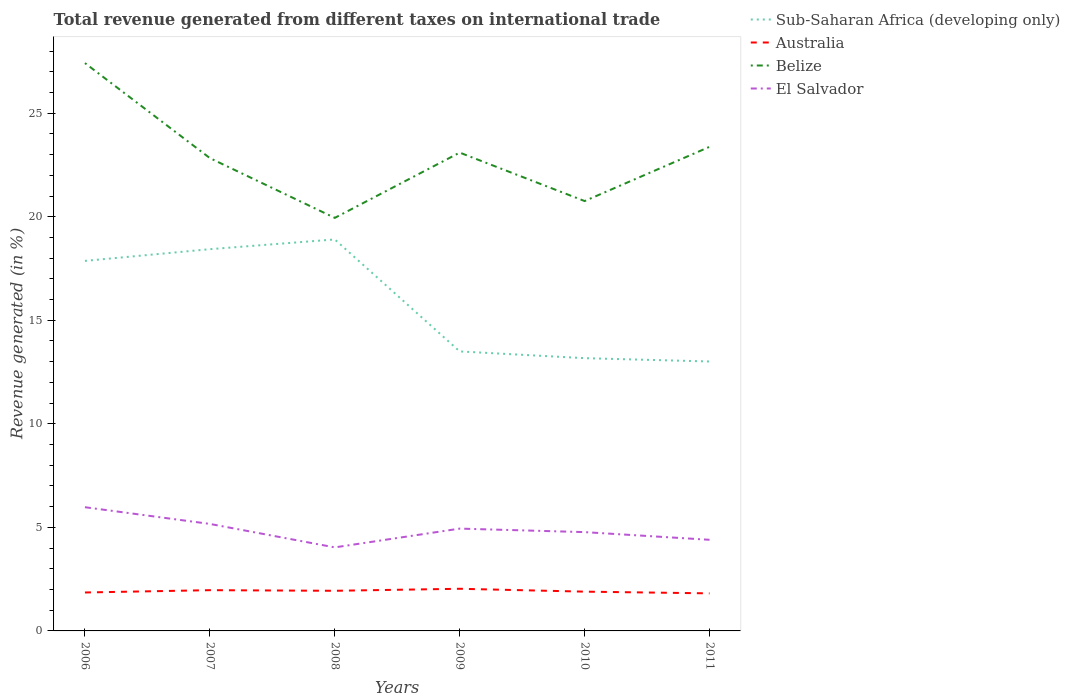How many different coloured lines are there?
Provide a short and direct response. 4. Does the line corresponding to Australia intersect with the line corresponding to Belize?
Your answer should be very brief. No. Across all years, what is the maximum total revenue generated in Sub-Saharan Africa (developing only)?
Offer a terse response. 13.01. In which year was the total revenue generated in Sub-Saharan Africa (developing only) maximum?
Offer a terse response. 2011. What is the total total revenue generated in Australia in the graph?
Give a very brief answer. 0.08. What is the difference between the highest and the second highest total revenue generated in Belize?
Your answer should be very brief. 7.47. Is the total revenue generated in El Salvador strictly greater than the total revenue generated in Belize over the years?
Keep it short and to the point. Yes. What is the difference between two consecutive major ticks on the Y-axis?
Ensure brevity in your answer.  5. Does the graph contain any zero values?
Provide a succinct answer. No. Where does the legend appear in the graph?
Your answer should be compact. Top right. What is the title of the graph?
Provide a short and direct response. Total revenue generated from different taxes on international trade. Does "Korea (Democratic)" appear as one of the legend labels in the graph?
Your answer should be very brief. No. What is the label or title of the Y-axis?
Offer a very short reply. Revenue generated (in %). What is the Revenue generated (in %) in Sub-Saharan Africa (developing only) in 2006?
Your answer should be compact. 17.87. What is the Revenue generated (in %) in Australia in 2006?
Your answer should be very brief. 1.86. What is the Revenue generated (in %) of Belize in 2006?
Offer a very short reply. 27.42. What is the Revenue generated (in %) of El Salvador in 2006?
Your answer should be compact. 5.97. What is the Revenue generated (in %) of Sub-Saharan Africa (developing only) in 2007?
Your response must be concise. 18.43. What is the Revenue generated (in %) of Australia in 2007?
Offer a terse response. 1.97. What is the Revenue generated (in %) in Belize in 2007?
Keep it short and to the point. 22.83. What is the Revenue generated (in %) of El Salvador in 2007?
Provide a succinct answer. 5.17. What is the Revenue generated (in %) of Sub-Saharan Africa (developing only) in 2008?
Provide a short and direct response. 18.9. What is the Revenue generated (in %) in Australia in 2008?
Provide a succinct answer. 1.94. What is the Revenue generated (in %) of Belize in 2008?
Keep it short and to the point. 19.94. What is the Revenue generated (in %) of El Salvador in 2008?
Provide a short and direct response. 4.03. What is the Revenue generated (in %) of Sub-Saharan Africa (developing only) in 2009?
Ensure brevity in your answer.  13.5. What is the Revenue generated (in %) in Australia in 2009?
Give a very brief answer. 2.04. What is the Revenue generated (in %) of Belize in 2009?
Keep it short and to the point. 23.1. What is the Revenue generated (in %) in El Salvador in 2009?
Ensure brevity in your answer.  4.94. What is the Revenue generated (in %) in Sub-Saharan Africa (developing only) in 2010?
Your answer should be very brief. 13.17. What is the Revenue generated (in %) of Australia in 2010?
Your answer should be very brief. 1.9. What is the Revenue generated (in %) of Belize in 2010?
Your answer should be very brief. 20.76. What is the Revenue generated (in %) in El Salvador in 2010?
Your response must be concise. 4.77. What is the Revenue generated (in %) of Sub-Saharan Africa (developing only) in 2011?
Provide a short and direct response. 13.01. What is the Revenue generated (in %) of Australia in 2011?
Your answer should be compact. 1.81. What is the Revenue generated (in %) of Belize in 2011?
Offer a very short reply. 23.37. What is the Revenue generated (in %) of El Salvador in 2011?
Your answer should be very brief. 4.4. Across all years, what is the maximum Revenue generated (in %) in Sub-Saharan Africa (developing only)?
Provide a succinct answer. 18.9. Across all years, what is the maximum Revenue generated (in %) in Australia?
Offer a terse response. 2.04. Across all years, what is the maximum Revenue generated (in %) of Belize?
Your answer should be compact. 27.42. Across all years, what is the maximum Revenue generated (in %) in El Salvador?
Offer a terse response. 5.97. Across all years, what is the minimum Revenue generated (in %) in Sub-Saharan Africa (developing only)?
Provide a short and direct response. 13.01. Across all years, what is the minimum Revenue generated (in %) of Australia?
Keep it short and to the point. 1.81. Across all years, what is the minimum Revenue generated (in %) in Belize?
Your response must be concise. 19.94. Across all years, what is the minimum Revenue generated (in %) in El Salvador?
Your answer should be compact. 4.03. What is the total Revenue generated (in %) of Sub-Saharan Africa (developing only) in the graph?
Provide a succinct answer. 94.88. What is the total Revenue generated (in %) in Australia in the graph?
Your answer should be very brief. 11.51. What is the total Revenue generated (in %) in Belize in the graph?
Keep it short and to the point. 137.42. What is the total Revenue generated (in %) in El Salvador in the graph?
Your answer should be compact. 29.28. What is the difference between the Revenue generated (in %) in Sub-Saharan Africa (developing only) in 2006 and that in 2007?
Your answer should be very brief. -0.57. What is the difference between the Revenue generated (in %) of Australia in 2006 and that in 2007?
Offer a terse response. -0.11. What is the difference between the Revenue generated (in %) in Belize in 2006 and that in 2007?
Your answer should be compact. 4.59. What is the difference between the Revenue generated (in %) in El Salvador in 2006 and that in 2007?
Make the answer very short. 0.81. What is the difference between the Revenue generated (in %) in Sub-Saharan Africa (developing only) in 2006 and that in 2008?
Provide a succinct answer. -1.04. What is the difference between the Revenue generated (in %) in Australia in 2006 and that in 2008?
Your answer should be compact. -0.08. What is the difference between the Revenue generated (in %) in Belize in 2006 and that in 2008?
Make the answer very short. 7.47. What is the difference between the Revenue generated (in %) of El Salvador in 2006 and that in 2008?
Your answer should be very brief. 1.94. What is the difference between the Revenue generated (in %) in Sub-Saharan Africa (developing only) in 2006 and that in 2009?
Make the answer very short. 4.37. What is the difference between the Revenue generated (in %) of Australia in 2006 and that in 2009?
Offer a very short reply. -0.18. What is the difference between the Revenue generated (in %) of Belize in 2006 and that in 2009?
Your answer should be compact. 4.32. What is the difference between the Revenue generated (in %) of El Salvador in 2006 and that in 2009?
Your answer should be very brief. 1.03. What is the difference between the Revenue generated (in %) of Sub-Saharan Africa (developing only) in 2006 and that in 2010?
Ensure brevity in your answer.  4.7. What is the difference between the Revenue generated (in %) in Australia in 2006 and that in 2010?
Your answer should be very brief. -0.04. What is the difference between the Revenue generated (in %) in Belize in 2006 and that in 2010?
Your answer should be compact. 6.66. What is the difference between the Revenue generated (in %) of El Salvador in 2006 and that in 2010?
Make the answer very short. 1.2. What is the difference between the Revenue generated (in %) of Sub-Saharan Africa (developing only) in 2006 and that in 2011?
Your response must be concise. 4.86. What is the difference between the Revenue generated (in %) in Australia in 2006 and that in 2011?
Keep it short and to the point. 0.04. What is the difference between the Revenue generated (in %) in Belize in 2006 and that in 2011?
Your answer should be very brief. 4.04. What is the difference between the Revenue generated (in %) in El Salvador in 2006 and that in 2011?
Provide a short and direct response. 1.57. What is the difference between the Revenue generated (in %) in Sub-Saharan Africa (developing only) in 2007 and that in 2008?
Keep it short and to the point. -0.47. What is the difference between the Revenue generated (in %) in Australia in 2007 and that in 2008?
Give a very brief answer. 0.03. What is the difference between the Revenue generated (in %) in Belize in 2007 and that in 2008?
Give a very brief answer. 2.89. What is the difference between the Revenue generated (in %) in El Salvador in 2007 and that in 2008?
Offer a terse response. 1.13. What is the difference between the Revenue generated (in %) of Sub-Saharan Africa (developing only) in 2007 and that in 2009?
Offer a terse response. 4.94. What is the difference between the Revenue generated (in %) in Australia in 2007 and that in 2009?
Your answer should be compact. -0.07. What is the difference between the Revenue generated (in %) in Belize in 2007 and that in 2009?
Offer a very short reply. -0.27. What is the difference between the Revenue generated (in %) of El Salvador in 2007 and that in 2009?
Provide a short and direct response. 0.23. What is the difference between the Revenue generated (in %) in Sub-Saharan Africa (developing only) in 2007 and that in 2010?
Keep it short and to the point. 5.26. What is the difference between the Revenue generated (in %) in Australia in 2007 and that in 2010?
Ensure brevity in your answer.  0.07. What is the difference between the Revenue generated (in %) of Belize in 2007 and that in 2010?
Your answer should be very brief. 2.07. What is the difference between the Revenue generated (in %) in El Salvador in 2007 and that in 2010?
Make the answer very short. 0.4. What is the difference between the Revenue generated (in %) in Sub-Saharan Africa (developing only) in 2007 and that in 2011?
Ensure brevity in your answer.  5.42. What is the difference between the Revenue generated (in %) in Australia in 2007 and that in 2011?
Keep it short and to the point. 0.15. What is the difference between the Revenue generated (in %) of Belize in 2007 and that in 2011?
Offer a terse response. -0.54. What is the difference between the Revenue generated (in %) in El Salvador in 2007 and that in 2011?
Your answer should be very brief. 0.77. What is the difference between the Revenue generated (in %) in Sub-Saharan Africa (developing only) in 2008 and that in 2009?
Give a very brief answer. 5.41. What is the difference between the Revenue generated (in %) in Australia in 2008 and that in 2009?
Your answer should be compact. -0.1. What is the difference between the Revenue generated (in %) of Belize in 2008 and that in 2009?
Your answer should be compact. -3.15. What is the difference between the Revenue generated (in %) of El Salvador in 2008 and that in 2009?
Ensure brevity in your answer.  -0.91. What is the difference between the Revenue generated (in %) in Sub-Saharan Africa (developing only) in 2008 and that in 2010?
Provide a succinct answer. 5.73. What is the difference between the Revenue generated (in %) of Australia in 2008 and that in 2010?
Give a very brief answer. 0.04. What is the difference between the Revenue generated (in %) in Belize in 2008 and that in 2010?
Give a very brief answer. -0.81. What is the difference between the Revenue generated (in %) of El Salvador in 2008 and that in 2010?
Provide a short and direct response. -0.74. What is the difference between the Revenue generated (in %) in Sub-Saharan Africa (developing only) in 2008 and that in 2011?
Provide a short and direct response. 5.89. What is the difference between the Revenue generated (in %) in Australia in 2008 and that in 2011?
Your response must be concise. 0.12. What is the difference between the Revenue generated (in %) in Belize in 2008 and that in 2011?
Ensure brevity in your answer.  -3.43. What is the difference between the Revenue generated (in %) of El Salvador in 2008 and that in 2011?
Provide a succinct answer. -0.37. What is the difference between the Revenue generated (in %) of Sub-Saharan Africa (developing only) in 2009 and that in 2010?
Your answer should be compact. 0.33. What is the difference between the Revenue generated (in %) in Australia in 2009 and that in 2010?
Provide a succinct answer. 0.14. What is the difference between the Revenue generated (in %) of Belize in 2009 and that in 2010?
Provide a short and direct response. 2.34. What is the difference between the Revenue generated (in %) in El Salvador in 2009 and that in 2010?
Give a very brief answer. 0.17. What is the difference between the Revenue generated (in %) in Sub-Saharan Africa (developing only) in 2009 and that in 2011?
Your answer should be compact. 0.49. What is the difference between the Revenue generated (in %) in Australia in 2009 and that in 2011?
Offer a terse response. 0.22. What is the difference between the Revenue generated (in %) in Belize in 2009 and that in 2011?
Provide a short and direct response. -0.28. What is the difference between the Revenue generated (in %) in El Salvador in 2009 and that in 2011?
Provide a succinct answer. 0.54. What is the difference between the Revenue generated (in %) of Sub-Saharan Africa (developing only) in 2010 and that in 2011?
Your answer should be compact. 0.16. What is the difference between the Revenue generated (in %) in Australia in 2010 and that in 2011?
Provide a succinct answer. 0.08. What is the difference between the Revenue generated (in %) in Belize in 2010 and that in 2011?
Ensure brevity in your answer.  -2.62. What is the difference between the Revenue generated (in %) in El Salvador in 2010 and that in 2011?
Your answer should be compact. 0.37. What is the difference between the Revenue generated (in %) of Sub-Saharan Africa (developing only) in 2006 and the Revenue generated (in %) of Australia in 2007?
Provide a succinct answer. 15.9. What is the difference between the Revenue generated (in %) in Sub-Saharan Africa (developing only) in 2006 and the Revenue generated (in %) in Belize in 2007?
Your response must be concise. -4.96. What is the difference between the Revenue generated (in %) of Sub-Saharan Africa (developing only) in 2006 and the Revenue generated (in %) of El Salvador in 2007?
Make the answer very short. 12.7. What is the difference between the Revenue generated (in %) in Australia in 2006 and the Revenue generated (in %) in Belize in 2007?
Ensure brevity in your answer.  -20.97. What is the difference between the Revenue generated (in %) in Australia in 2006 and the Revenue generated (in %) in El Salvador in 2007?
Provide a short and direct response. -3.31. What is the difference between the Revenue generated (in %) in Belize in 2006 and the Revenue generated (in %) in El Salvador in 2007?
Ensure brevity in your answer.  22.25. What is the difference between the Revenue generated (in %) of Sub-Saharan Africa (developing only) in 2006 and the Revenue generated (in %) of Australia in 2008?
Provide a short and direct response. 15.93. What is the difference between the Revenue generated (in %) in Sub-Saharan Africa (developing only) in 2006 and the Revenue generated (in %) in Belize in 2008?
Offer a terse response. -2.08. What is the difference between the Revenue generated (in %) of Sub-Saharan Africa (developing only) in 2006 and the Revenue generated (in %) of El Salvador in 2008?
Offer a very short reply. 13.83. What is the difference between the Revenue generated (in %) of Australia in 2006 and the Revenue generated (in %) of Belize in 2008?
Your response must be concise. -18.09. What is the difference between the Revenue generated (in %) of Australia in 2006 and the Revenue generated (in %) of El Salvador in 2008?
Ensure brevity in your answer.  -2.18. What is the difference between the Revenue generated (in %) in Belize in 2006 and the Revenue generated (in %) in El Salvador in 2008?
Provide a short and direct response. 23.38. What is the difference between the Revenue generated (in %) in Sub-Saharan Africa (developing only) in 2006 and the Revenue generated (in %) in Australia in 2009?
Your response must be concise. 15.83. What is the difference between the Revenue generated (in %) in Sub-Saharan Africa (developing only) in 2006 and the Revenue generated (in %) in Belize in 2009?
Provide a succinct answer. -5.23. What is the difference between the Revenue generated (in %) in Sub-Saharan Africa (developing only) in 2006 and the Revenue generated (in %) in El Salvador in 2009?
Your answer should be compact. 12.93. What is the difference between the Revenue generated (in %) of Australia in 2006 and the Revenue generated (in %) of Belize in 2009?
Keep it short and to the point. -21.24. What is the difference between the Revenue generated (in %) of Australia in 2006 and the Revenue generated (in %) of El Salvador in 2009?
Your answer should be compact. -3.08. What is the difference between the Revenue generated (in %) in Belize in 2006 and the Revenue generated (in %) in El Salvador in 2009?
Ensure brevity in your answer.  22.48. What is the difference between the Revenue generated (in %) of Sub-Saharan Africa (developing only) in 2006 and the Revenue generated (in %) of Australia in 2010?
Provide a short and direct response. 15.97. What is the difference between the Revenue generated (in %) in Sub-Saharan Africa (developing only) in 2006 and the Revenue generated (in %) in Belize in 2010?
Keep it short and to the point. -2.89. What is the difference between the Revenue generated (in %) of Sub-Saharan Africa (developing only) in 2006 and the Revenue generated (in %) of El Salvador in 2010?
Provide a succinct answer. 13.1. What is the difference between the Revenue generated (in %) of Australia in 2006 and the Revenue generated (in %) of Belize in 2010?
Offer a terse response. -18.9. What is the difference between the Revenue generated (in %) in Australia in 2006 and the Revenue generated (in %) in El Salvador in 2010?
Keep it short and to the point. -2.91. What is the difference between the Revenue generated (in %) in Belize in 2006 and the Revenue generated (in %) in El Salvador in 2010?
Offer a very short reply. 22.65. What is the difference between the Revenue generated (in %) in Sub-Saharan Africa (developing only) in 2006 and the Revenue generated (in %) in Australia in 2011?
Make the answer very short. 16.05. What is the difference between the Revenue generated (in %) in Sub-Saharan Africa (developing only) in 2006 and the Revenue generated (in %) in Belize in 2011?
Provide a succinct answer. -5.51. What is the difference between the Revenue generated (in %) in Sub-Saharan Africa (developing only) in 2006 and the Revenue generated (in %) in El Salvador in 2011?
Keep it short and to the point. 13.47. What is the difference between the Revenue generated (in %) in Australia in 2006 and the Revenue generated (in %) in Belize in 2011?
Keep it short and to the point. -21.52. What is the difference between the Revenue generated (in %) in Australia in 2006 and the Revenue generated (in %) in El Salvador in 2011?
Ensure brevity in your answer.  -2.54. What is the difference between the Revenue generated (in %) of Belize in 2006 and the Revenue generated (in %) of El Salvador in 2011?
Your answer should be compact. 23.02. What is the difference between the Revenue generated (in %) in Sub-Saharan Africa (developing only) in 2007 and the Revenue generated (in %) in Australia in 2008?
Your response must be concise. 16.49. What is the difference between the Revenue generated (in %) of Sub-Saharan Africa (developing only) in 2007 and the Revenue generated (in %) of Belize in 2008?
Your answer should be very brief. -1.51. What is the difference between the Revenue generated (in %) of Sub-Saharan Africa (developing only) in 2007 and the Revenue generated (in %) of El Salvador in 2008?
Make the answer very short. 14.4. What is the difference between the Revenue generated (in %) in Australia in 2007 and the Revenue generated (in %) in Belize in 2008?
Provide a short and direct response. -17.98. What is the difference between the Revenue generated (in %) of Australia in 2007 and the Revenue generated (in %) of El Salvador in 2008?
Make the answer very short. -2.07. What is the difference between the Revenue generated (in %) in Belize in 2007 and the Revenue generated (in %) in El Salvador in 2008?
Your answer should be very brief. 18.8. What is the difference between the Revenue generated (in %) in Sub-Saharan Africa (developing only) in 2007 and the Revenue generated (in %) in Australia in 2009?
Your response must be concise. 16.4. What is the difference between the Revenue generated (in %) in Sub-Saharan Africa (developing only) in 2007 and the Revenue generated (in %) in Belize in 2009?
Offer a terse response. -4.66. What is the difference between the Revenue generated (in %) in Sub-Saharan Africa (developing only) in 2007 and the Revenue generated (in %) in El Salvador in 2009?
Give a very brief answer. 13.49. What is the difference between the Revenue generated (in %) in Australia in 2007 and the Revenue generated (in %) in Belize in 2009?
Offer a very short reply. -21.13. What is the difference between the Revenue generated (in %) of Australia in 2007 and the Revenue generated (in %) of El Salvador in 2009?
Provide a short and direct response. -2.97. What is the difference between the Revenue generated (in %) of Belize in 2007 and the Revenue generated (in %) of El Salvador in 2009?
Your answer should be very brief. 17.89. What is the difference between the Revenue generated (in %) of Sub-Saharan Africa (developing only) in 2007 and the Revenue generated (in %) of Australia in 2010?
Your answer should be very brief. 16.54. What is the difference between the Revenue generated (in %) of Sub-Saharan Africa (developing only) in 2007 and the Revenue generated (in %) of Belize in 2010?
Offer a terse response. -2.32. What is the difference between the Revenue generated (in %) of Sub-Saharan Africa (developing only) in 2007 and the Revenue generated (in %) of El Salvador in 2010?
Give a very brief answer. 13.66. What is the difference between the Revenue generated (in %) of Australia in 2007 and the Revenue generated (in %) of Belize in 2010?
Keep it short and to the point. -18.79. What is the difference between the Revenue generated (in %) of Australia in 2007 and the Revenue generated (in %) of El Salvador in 2010?
Your response must be concise. -2.8. What is the difference between the Revenue generated (in %) of Belize in 2007 and the Revenue generated (in %) of El Salvador in 2010?
Your response must be concise. 18.06. What is the difference between the Revenue generated (in %) in Sub-Saharan Africa (developing only) in 2007 and the Revenue generated (in %) in Australia in 2011?
Make the answer very short. 16.62. What is the difference between the Revenue generated (in %) in Sub-Saharan Africa (developing only) in 2007 and the Revenue generated (in %) in Belize in 2011?
Your answer should be compact. -4.94. What is the difference between the Revenue generated (in %) of Sub-Saharan Africa (developing only) in 2007 and the Revenue generated (in %) of El Salvador in 2011?
Keep it short and to the point. 14.03. What is the difference between the Revenue generated (in %) in Australia in 2007 and the Revenue generated (in %) in Belize in 2011?
Ensure brevity in your answer.  -21.41. What is the difference between the Revenue generated (in %) in Australia in 2007 and the Revenue generated (in %) in El Salvador in 2011?
Provide a succinct answer. -2.43. What is the difference between the Revenue generated (in %) of Belize in 2007 and the Revenue generated (in %) of El Salvador in 2011?
Offer a very short reply. 18.43. What is the difference between the Revenue generated (in %) in Sub-Saharan Africa (developing only) in 2008 and the Revenue generated (in %) in Australia in 2009?
Provide a succinct answer. 16.87. What is the difference between the Revenue generated (in %) in Sub-Saharan Africa (developing only) in 2008 and the Revenue generated (in %) in Belize in 2009?
Make the answer very short. -4.19. What is the difference between the Revenue generated (in %) in Sub-Saharan Africa (developing only) in 2008 and the Revenue generated (in %) in El Salvador in 2009?
Ensure brevity in your answer.  13.96. What is the difference between the Revenue generated (in %) of Australia in 2008 and the Revenue generated (in %) of Belize in 2009?
Make the answer very short. -21.16. What is the difference between the Revenue generated (in %) of Australia in 2008 and the Revenue generated (in %) of El Salvador in 2009?
Give a very brief answer. -3. What is the difference between the Revenue generated (in %) of Belize in 2008 and the Revenue generated (in %) of El Salvador in 2009?
Provide a short and direct response. 15. What is the difference between the Revenue generated (in %) in Sub-Saharan Africa (developing only) in 2008 and the Revenue generated (in %) in Australia in 2010?
Your answer should be very brief. 17.01. What is the difference between the Revenue generated (in %) in Sub-Saharan Africa (developing only) in 2008 and the Revenue generated (in %) in Belize in 2010?
Provide a short and direct response. -1.85. What is the difference between the Revenue generated (in %) in Sub-Saharan Africa (developing only) in 2008 and the Revenue generated (in %) in El Salvador in 2010?
Your response must be concise. 14.13. What is the difference between the Revenue generated (in %) of Australia in 2008 and the Revenue generated (in %) of Belize in 2010?
Give a very brief answer. -18.82. What is the difference between the Revenue generated (in %) of Australia in 2008 and the Revenue generated (in %) of El Salvador in 2010?
Offer a terse response. -2.83. What is the difference between the Revenue generated (in %) in Belize in 2008 and the Revenue generated (in %) in El Salvador in 2010?
Ensure brevity in your answer.  15.17. What is the difference between the Revenue generated (in %) in Sub-Saharan Africa (developing only) in 2008 and the Revenue generated (in %) in Australia in 2011?
Keep it short and to the point. 17.09. What is the difference between the Revenue generated (in %) in Sub-Saharan Africa (developing only) in 2008 and the Revenue generated (in %) in Belize in 2011?
Make the answer very short. -4.47. What is the difference between the Revenue generated (in %) of Sub-Saharan Africa (developing only) in 2008 and the Revenue generated (in %) of El Salvador in 2011?
Your answer should be compact. 14.5. What is the difference between the Revenue generated (in %) of Australia in 2008 and the Revenue generated (in %) of Belize in 2011?
Offer a very short reply. -21.44. What is the difference between the Revenue generated (in %) of Australia in 2008 and the Revenue generated (in %) of El Salvador in 2011?
Offer a terse response. -2.46. What is the difference between the Revenue generated (in %) in Belize in 2008 and the Revenue generated (in %) in El Salvador in 2011?
Provide a short and direct response. 15.54. What is the difference between the Revenue generated (in %) of Sub-Saharan Africa (developing only) in 2009 and the Revenue generated (in %) of Australia in 2010?
Your response must be concise. 11.6. What is the difference between the Revenue generated (in %) of Sub-Saharan Africa (developing only) in 2009 and the Revenue generated (in %) of Belize in 2010?
Your answer should be very brief. -7.26. What is the difference between the Revenue generated (in %) in Sub-Saharan Africa (developing only) in 2009 and the Revenue generated (in %) in El Salvador in 2010?
Your response must be concise. 8.73. What is the difference between the Revenue generated (in %) in Australia in 2009 and the Revenue generated (in %) in Belize in 2010?
Keep it short and to the point. -18.72. What is the difference between the Revenue generated (in %) of Australia in 2009 and the Revenue generated (in %) of El Salvador in 2010?
Provide a succinct answer. -2.74. What is the difference between the Revenue generated (in %) in Belize in 2009 and the Revenue generated (in %) in El Salvador in 2010?
Make the answer very short. 18.33. What is the difference between the Revenue generated (in %) in Sub-Saharan Africa (developing only) in 2009 and the Revenue generated (in %) in Australia in 2011?
Your answer should be compact. 11.68. What is the difference between the Revenue generated (in %) in Sub-Saharan Africa (developing only) in 2009 and the Revenue generated (in %) in Belize in 2011?
Provide a succinct answer. -9.88. What is the difference between the Revenue generated (in %) of Sub-Saharan Africa (developing only) in 2009 and the Revenue generated (in %) of El Salvador in 2011?
Provide a short and direct response. 9.1. What is the difference between the Revenue generated (in %) of Australia in 2009 and the Revenue generated (in %) of Belize in 2011?
Give a very brief answer. -21.34. What is the difference between the Revenue generated (in %) in Australia in 2009 and the Revenue generated (in %) in El Salvador in 2011?
Offer a very short reply. -2.36. What is the difference between the Revenue generated (in %) of Belize in 2009 and the Revenue generated (in %) of El Salvador in 2011?
Keep it short and to the point. 18.7. What is the difference between the Revenue generated (in %) in Sub-Saharan Africa (developing only) in 2010 and the Revenue generated (in %) in Australia in 2011?
Your answer should be very brief. 11.36. What is the difference between the Revenue generated (in %) in Sub-Saharan Africa (developing only) in 2010 and the Revenue generated (in %) in Belize in 2011?
Offer a very short reply. -10.21. What is the difference between the Revenue generated (in %) in Sub-Saharan Africa (developing only) in 2010 and the Revenue generated (in %) in El Salvador in 2011?
Give a very brief answer. 8.77. What is the difference between the Revenue generated (in %) in Australia in 2010 and the Revenue generated (in %) in Belize in 2011?
Your answer should be compact. -21.48. What is the difference between the Revenue generated (in %) of Australia in 2010 and the Revenue generated (in %) of El Salvador in 2011?
Make the answer very short. -2.5. What is the difference between the Revenue generated (in %) of Belize in 2010 and the Revenue generated (in %) of El Salvador in 2011?
Your answer should be compact. 16.36. What is the average Revenue generated (in %) in Sub-Saharan Africa (developing only) per year?
Your answer should be compact. 15.81. What is the average Revenue generated (in %) in Australia per year?
Offer a terse response. 1.92. What is the average Revenue generated (in %) in Belize per year?
Provide a short and direct response. 22.9. What is the average Revenue generated (in %) in El Salvador per year?
Offer a very short reply. 4.88. In the year 2006, what is the difference between the Revenue generated (in %) in Sub-Saharan Africa (developing only) and Revenue generated (in %) in Australia?
Give a very brief answer. 16.01. In the year 2006, what is the difference between the Revenue generated (in %) in Sub-Saharan Africa (developing only) and Revenue generated (in %) in Belize?
Make the answer very short. -9.55. In the year 2006, what is the difference between the Revenue generated (in %) in Sub-Saharan Africa (developing only) and Revenue generated (in %) in El Salvador?
Offer a very short reply. 11.89. In the year 2006, what is the difference between the Revenue generated (in %) in Australia and Revenue generated (in %) in Belize?
Your answer should be very brief. -25.56. In the year 2006, what is the difference between the Revenue generated (in %) in Australia and Revenue generated (in %) in El Salvador?
Offer a terse response. -4.12. In the year 2006, what is the difference between the Revenue generated (in %) in Belize and Revenue generated (in %) in El Salvador?
Ensure brevity in your answer.  21.44. In the year 2007, what is the difference between the Revenue generated (in %) of Sub-Saharan Africa (developing only) and Revenue generated (in %) of Australia?
Make the answer very short. 16.46. In the year 2007, what is the difference between the Revenue generated (in %) in Sub-Saharan Africa (developing only) and Revenue generated (in %) in Belize?
Give a very brief answer. -4.4. In the year 2007, what is the difference between the Revenue generated (in %) in Sub-Saharan Africa (developing only) and Revenue generated (in %) in El Salvador?
Make the answer very short. 13.27. In the year 2007, what is the difference between the Revenue generated (in %) in Australia and Revenue generated (in %) in Belize?
Offer a very short reply. -20.86. In the year 2007, what is the difference between the Revenue generated (in %) in Australia and Revenue generated (in %) in El Salvador?
Provide a succinct answer. -3.2. In the year 2007, what is the difference between the Revenue generated (in %) of Belize and Revenue generated (in %) of El Salvador?
Ensure brevity in your answer.  17.66. In the year 2008, what is the difference between the Revenue generated (in %) in Sub-Saharan Africa (developing only) and Revenue generated (in %) in Australia?
Your answer should be compact. 16.97. In the year 2008, what is the difference between the Revenue generated (in %) in Sub-Saharan Africa (developing only) and Revenue generated (in %) in Belize?
Offer a terse response. -1.04. In the year 2008, what is the difference between the Revenue generated (in %) in Sub-Saharan Africa (developing only) and Revenue generated (in %) in El Salvador?
Provide a succinct answer. 14.87. In the year 2008, what is the difference between the Revenue generated (in %) in Australia and Revenue generated (in %) in Belize?
Offer a very short reply. -18.01. In the year 2008, what is the difference between the Revenue generated (in %) of Australia and Revenue generated (in %) of El Salvador?
Provide a succinct answer. -2.1. In the year 2008, what is the difference between the Revenue generated (in %) of Belize and Revenue generated (in %) of El Salvador?
Offer a very short reply. 15.91. In the year 2009, what is the difference between the Revenue generated (in %) in Sub-Saharan Africa (developing only) and Revenue generated (in %) in Australia?
Offer a terse response. 11.46. In the year 2009, what is the difference between the Revenue generated (in %) of Sub-Saharan Africa (developing only) and Revenue generated (in %) of El Salvador?
Your answer should be very brief. 8.56. In the year 2009, what is the difference between the Revenue generated (in %) of Australia and Revenue generated (in %) of Belize?
Your answer should be compact. -21.06. In the year 2009, what is the difference between the Revenue generated (in %) of Australia and Revenue generated (in %) of El Salvador?
Provide a short and direct response. -2.9. In the year 2009, what is the difference between the Revenue generated (in %) of Belize and Revenue generated (in %) of El Salvador?
Ensure brevity in your answer.  18.16. In the year 2010, what is the difference between the Revenue generated (in %) in Sub-Saharan Africa (developing only) and Revenue generated (in %) in Australia?
Your response must be concise. 11.27. In the year 2010, what is the difference between the Revenue generated (in %) of Sub-Saharan Africa (developing only) and Revenue generated (in %) of Belize?
Offer a terse response. -7.59. In the year 2010, what is the difference between the Revenue generated (in %) in Sub-Saharan Africa (developing only) and Revenue generated (in %) in El Salvador?
Provide a succinct answer. 8.4. In the year 2010, what is the difference between the Revenue generated (in %) in Australia and Revenue generated (in %) in Belize?
Provide a succinct answer. -18.86. In the year 2010, what is the difference between the Revenue generated (in %) in Australia and Revenue generated (in %) in El Salvador?
Give a very brief answer. -2.87. In the year 2010, what is the difference between the Revenue generated (in %) in Belize and Revenue generated (in %) in El Salvador?
Provide a succinct answer. 15.99. In the year 2011, what is the difference between the Revenue generated (in %) in Sub-Saharan Africa (developing only) and Revenue generated (in %) in Australia?
Make the answer very short. 11.2. In the year 2011, what is the difference between the Revenue generated (in %) of Sub-Saharan Africa (developing only) and Revenue generated (in %) of Belize?
Your answer should be very brief. -10.37. In the year 2011, what is the difference between the Revenue generated (in %) in Sub-Saharan Africa (developing only) and Revenue generated (in %) in El Salvador?
Provide a succinct answer. 8.61. In the year 2011, what is the difference between the Revenue generated (in %) of Australia and Revenue generated (in %) of Belize?
Ensure brevity in your answer.  -21.56. In the year 2011, what is the difference between the Revenue generated (in %) of Australia and Revenue generated (in %) of El Salvador?
Offer a terse response. -2.59. In the year 2011, what is the difference between the Revenue generated (in %) of Belize and Revenue generated (in %) of El Salvador?
Give a very brief answer. 18.98. What is the ratio of the Revenue generated (in %) of Sub-Saharan Africa (developing only) in 2006 to that in 2007?
Offer a terse response. 0.97. What is the ratio of the Revenue generated (in %) of Australia in 2006 to that in 2007?
Offer a very short reply. 0.94. What is the ratio of the Revenue generated (in %) in Belize in 2006 to that in 2007?
Ensure brevity in your answer.  1.2. What is the ratio of the Revenue generated (in %) in El Salvador in 2006 to that in 2007?
Your answer should be very brief. 1.16. What is the ratio of the Revenue generated (in %) of Sub-Saharan Africa (developing only) in 2006 to that in 2008?
Your response must be concise. 0.95. What is the ratio of the Revenue generated (in %) of Australia in 2006 to that in 2008?
Make the answer very short. 0.96. What is the ratio of the Revenue generated (in %) of Belize in 2006 to that in 2008?
Ensure brevity in your answer.  1.37. What is the ratio of the Revenue generated (in %) of El Salvador in 2006 to that in 2008?
Offer a terse response. 1.48. What is the ratio of the Revenue generated (in %) in Sub-Saharan Africa (developing only) in 2006 to that in 2009?
Your answer should be very brief. 1.32. What is the ratio of the Revenue generated (in %) in Australia in 2006 to that in 2009?
Provide a short and direct response. 0.91. What is the ratio of the Revenue generated (in %) in Belize in 2006 to that in 2009?
Your answer should be compact. 1.19. What is the ratio of the Revenue generated (in %) of El Salvador in 2006 to that in 2009?
Provide a short and direct response. 1.21. What is the ratio of the Revenue generated (in %) of Sub-Saharan Africa (developing only) in 2006 to that in 2010?
Keep it short and to the point. 1.36. What is the ratio of the Revenue generated (in %) in Australia in 2006 to that in 2010?
Provide a short and direct response. 0.98. What is the ratio of the Revenue generated (in %) of Belize in 2006 to that in 2010?
Provide a short and direct response. 1.32. What is the ratio of the Revenue generated (in %) in El Salvador in 2006 to that in 2010?
Provide a short and direct response. 1.25. What is the ratio of the Revenue generated (in %) in Sub-Saharan Africa (developing only) in 2006 to that in 2011?
Give a very brief answer. 1.37. What is the ratio of the Revenue generated (in %) in Australia in 2006 to that in 2011?
Ensure brevity in your answer.  1.02. What is the ratio of the Revenue generated (in %) in Belize in 2006 to that in 2011?
Ensure brevity in your answer.  1.17. What is the ratio of the Revenue generated (in %) in El Salvador in 2006 to that in 2011?
Your response must be concise. 1.36. What is the ratio of the Revenue generated (in %) of Sub-Saharan Africa (developing only) in 2007 to that in 2008?
Your answer should be very brief. 0.98. What is the ratio of the Revenue generated (in %) of Australia in 2007 to that in 2008?
Your answer should be compact. 1.02. What is the ratio of the Revenue generated (in %) in Belize in 2007 to that in 2008?
Offer a very short reply. 1.14. What is the ratio of the Revenue generated (in %) of El Salvador in 2007 to that in 2008?
Keep it short and to the point. 1.28. What is the ratio of the Revenue generated (in %) of Sub-Saharan Africa (developing only) in 2007 to that in 2009?
Provide a short and direct response. 1.37. What is the ratio of the Revenue generated (in %) of Australia in 2007 to that in 2009?
Provide a short and direct response. 0.97. What is the ratio of the Revenue generated (in %) of El Salvador in 2007 to that in 2009?
Make the answer very short. 1.05. What is the ratio of the Revenue generated (in %) of Sub-Saharan Africa (developing only) in 2007 to that in 2010?
Give a very brief answer. 1.4. What is the ratio of the Revenue generated (in %) of Australia in 2007 to that in 2010?
Provide a succinct answer. 1.04. What is the ratio of the Revenue generated (in %) in Belize in 2007 to that in 2010?
Offer a terse response. 1.1. What is the ratio of the Revenue generated (in %) in El Salvador in 2007 to that in 2010?
Offer a terse response. 1.08. What is the ratio of the Revenue generated (in %) in Sub-Saharan Africa (developing only) in 2007 to that in 2011?
Your answer should be very brief. 1.42. What is the ratio of the Revenue generated (in %) in Australia in 2007 to that in 2011?
Provide a short and direct response. 1.08. What is the ratio of the Revenue generated (in %) of Belize in 2007 to that in 2011?
Ensure brevity in your answer.  0.98. What is the ratio of the Revenue generated (in %) of El Salvador in 2007 to that in 2011?
Offer a very short reply. 1.17. What is the ratio of the Revenue generated (in %) in Sub-Saharan Africa (developing only) in 2008 to that in 2009?
Ensure brevity in your answer.  1.4. What is the ratio of the Revenue generated (in %) in Australia in 2008 to that in 2009?
Offer a terse response. 0.95. What is the ratio of the Revenue generated (in %) of Belize in 2008 to that in 2009?
Your answer should be compact. 0.86. What is the ratio of the Revenue generated (in %) of El Salvador in 2008 to that in 2009?
Keep it short and to the point. 0.82. What is the ratio of the Revenue generated (in %) of Sub-Saharan Africa (developing only) in 2008 to that in 2010?
Keep it short and to the point. 1.44. What is the ratio of the Revenue generated (in %) in Australia in 2008 to that in 2010?
Provide a succinct answer. 1.02. What is the ratio of the Revenue generated (in %) in Belize in 2008 to that in 2010?
Ensure brevity in your answer.  0.96. What is the ratio of the Revenue generated (in %) in El Salvador in 2008 to that in 2010?
Keep it short and to the point. 0.85. What is the ratio of the Revenue generated (in %) of Sub-Saharan Africa (developing only) in 2008 to that in 2011?
Provide a succinct answer. 1.45. What is the ratio of the Revenue generated (in %) of Australia in 2008 to that in 2011?
Make the answer very short. 1.07. What is the ratio of the Revenue generated (in %) in Belize in 2008 to that in 2011?
Your answer should be very brief. 0.85. What is the ratio of the Revenue generated (in %) of El Salvador in 2008 to that in 2011?
Your answer should be compact. 0.92. What is the ratio of the Revenue generated (in %) of Sub-Saharan Africa (developing only) in 2009 to that in 2010?
Offer a terse response. 1.02. What is the ratio of the Revenue generated (in %) of Australia in 2009 to that in 2010?
Give a very brief answer. 1.07. What is the ratio of the Revenue generated (in %) in Belize in 2009 to that in 2010?
Provide a short and direct response. 1.11. What is the ratio of the Revenue generated (in %) in El Salvador in 2009 to that in 2010?
Your answer should be compact. 1.04. What is the ratio of the Revenue generated (in %) in Sub-Saharan Africa (developing only) in 2009 to that in 2011?
Your response must be concise. 1.04. What is the ratio of the Revenue generated (in %) of Australia in 2009 to that in 2011?
Your answer should be compact. 1.12. What is the ratio of the Revenue generated (in %) in El Salvador in 2009 to that in 2011?
Offer a very short reply. 1.12. What is the ratio of the Revenue generated (in %) in Sub-Saharan Africa (developing only) in 2010 to that in 2011?
Offer a very short reply. 1.01. What is the ratio of the Revenue generated (in %) in Australia in 2010 to that in 2011?
Offer a terse response. 1.05. What is the ratio of the Revenue generated (in %) in Belize in 2010 to that in 2011?
Provide a succinct answer. 0.89. What is the ratio of the Revenue generated (in %) of El Salvador in 2010 to that in 2011?
Provide a succinct answer. 1.08. What is the difference between the highest and the second highest Revenue generated (in %) in Sub-Saharan Africa (developing only)?
Your response must be concise. 0.47. What is the difference between the highest and the second highest Revenue generated (in %) in Australia?
Offer a very short reply. 0.07. What is the difference between the highest and the second highest Revenue generated (in %) of Belize?
Your response must be concise. 4.04. What is the difference between the highest and the second highest Revenue generated (in %) in El Salvador?
Offer a terse response. 0.81. What is the difference between the highest and the lowest Revenue generated (in %) in Sub-Saharan Africa (developing only)?
Ensure brevity in your answer.  5.89. What is the difference between the highest and the lowest Revenue generated (in %) of Australia?
Offer a very short reply. 0.22. What is the difference between the highest and the lowest Revenue generated (in %) of Belize?
Provide a succinct answer. 7.47. What is the difference between the highest and the lowest Revenue generated (in %) in El Salvador?
Ensure brevity in your answer.  1.94. 